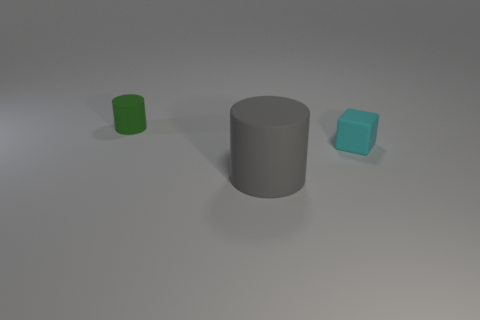Does the cyan rubber cube have the same size as the gray matte object?
Your answer should be very brief. No. There is a cylinder that is in front of the small cyan cube; what material is it?
Ensure brevity in your answer.  Rubber. Is there anything else that has the same size as the gray thing?
Give a very brief answer. No. Are there any cyan matte objects behind the small cyan thing?
Provide a succinct answer. No. What is the shape of the gray rubber thing?
Offer a very short reply. Cylinder. How many things are cylinders that are behind the small matte cube or tiny green things?
Keep it short and to the point. 1. There is another object that is the same shape as the gray object; what color is it?
Your response must be concise. Green. What color is the large cylinder?
Make the answer very short. Gray. The tiny matte thing that is in front of the small matte object behind the small rubber object that is to the right of the big object is what color?
Provide a succinct answer. Cyan. There is a large thing; is it the same shape as the tiny object to the left of the matte block?
Ensure brevity in your answer.  Yes. 